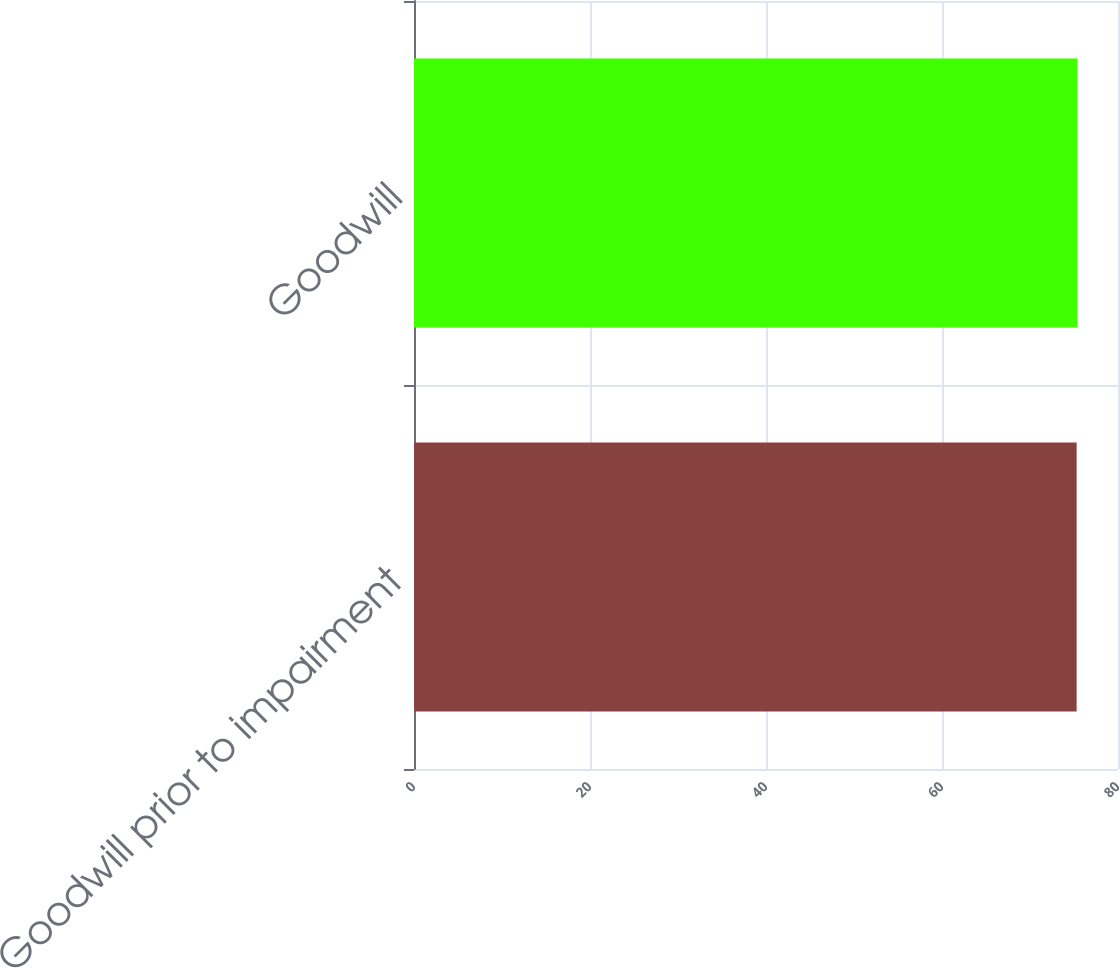<chart> <loc_0><loc_0><loc_500><loc_500><bar_chart><fcel>Goodwill prior to impairment<fcel>Goodwill<nl><fcel>75.3<fcel>75.4<nl></chart> 